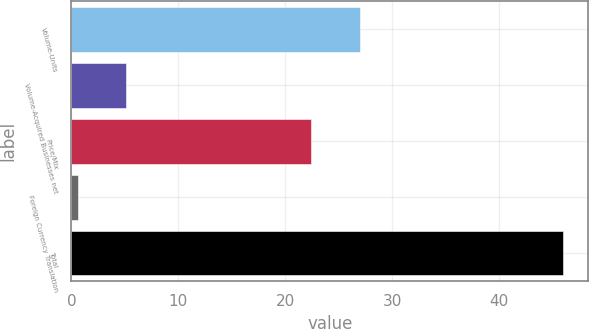Convert chart. <chart><loc_0><loc_0><loc_500><loc_500><bar_chart><fcel>Volume-Units<fcel>Volume-Acquired Businesses net<fcel>Price/Mix<fcel>Foreign Currency Translation<fcel>Total<nl><fcel>26.94<fcel>5.14<fcel>22.4<fcel>0.6<fcel>46<nl></chart> 